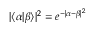<formula> <loc_0><loc_0><loc_500><loc_500>| \langle \alpha | \beta \rangle | ^ { 2 } = e ^ { - | \alpha - \beta | ^ { 2 } }</formula> 